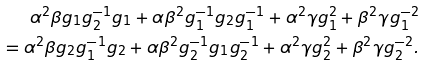<formula> <loc_0><loc_0><loc_500><loc_500>\alpha ^ { 2 } \beta g _ { 1 } g ^ { - 1 } _ { 2 } g _ { 1 } + \alpha \beta ^ { 2 } g _ { 1 } ^ { - 1 } g _ { 2 } g ^ { - 1 } _ { 1 } + \alpha ^ { 2 } \gamma g ^ { 2 } _ { 1 } + \beta ^ { 2 } \gamma g ^ { - 2 } _ { 1 } \\ = \alpha ^ { 2 } \beta g _ { 2 } g ^ { - 1 } _ { 1 } g _ { 2 } + \alpha \beta ^ { 2 } g ^ { - 1 } _ { 2 } g _ { 1 } g ^ { - 1 } _ { 2 } + \alpha ^ { 2 } \gamma g ^ { 2 } _ { 2 } + \beta ^ { 2 } \gamma g ^ { - 2 } _ { 2 } .</formula> 